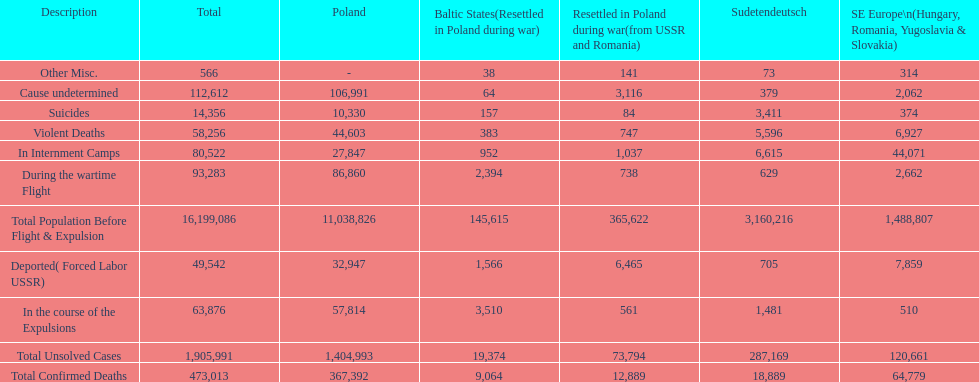What is the total of deaths in internment camps and during the wartime flight? 173,805. 